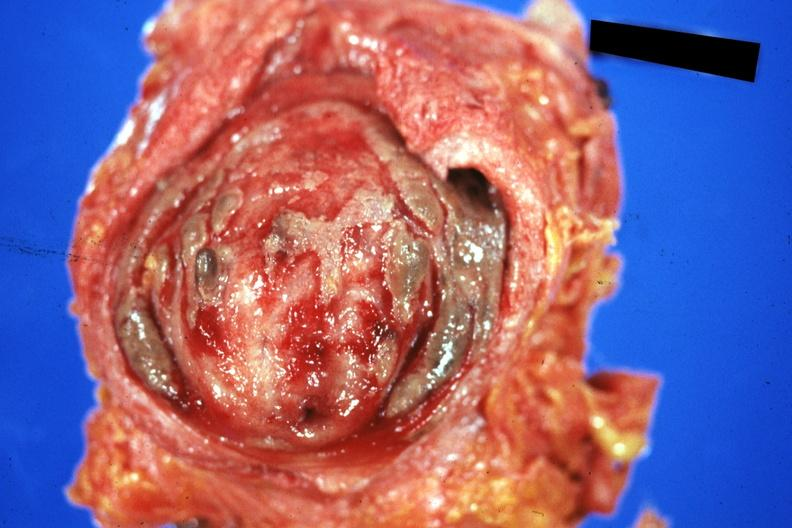what is present?
Answer the question using a single word or phrase. Bladder 